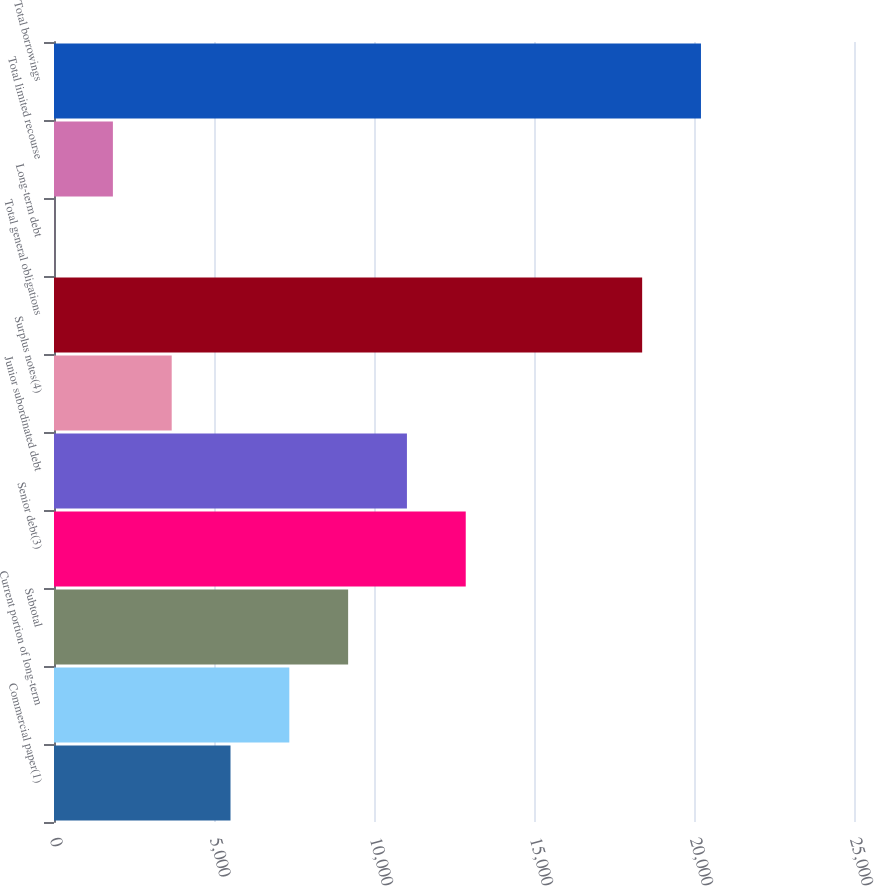Convert chart to OTSL. <chart><loc_0><loc_0><loc_500><loc_500><bar_chart><fcel>Commercial paper(1)<fcel>Current portion of long-term<fcel>Subtotal<fcel>Senior debt(3)<fcel>Junior subordinated debt<fcel>Surplus notes(4)<fcel>Total general obligations<fcel>Long-term debt<fcel>Total limited recourse<fcel>Total borrowings<nl><fcel>5515.99<fcel>7353.7<fcel>9191.41<fcel>12866.8<fcel>11029.1<fcel>3678.28<fcel>18380<fcel>2.86<fcel>1840.57<fcel>20217.7<nl></chart> 